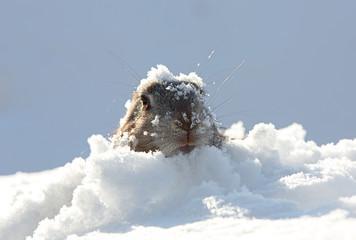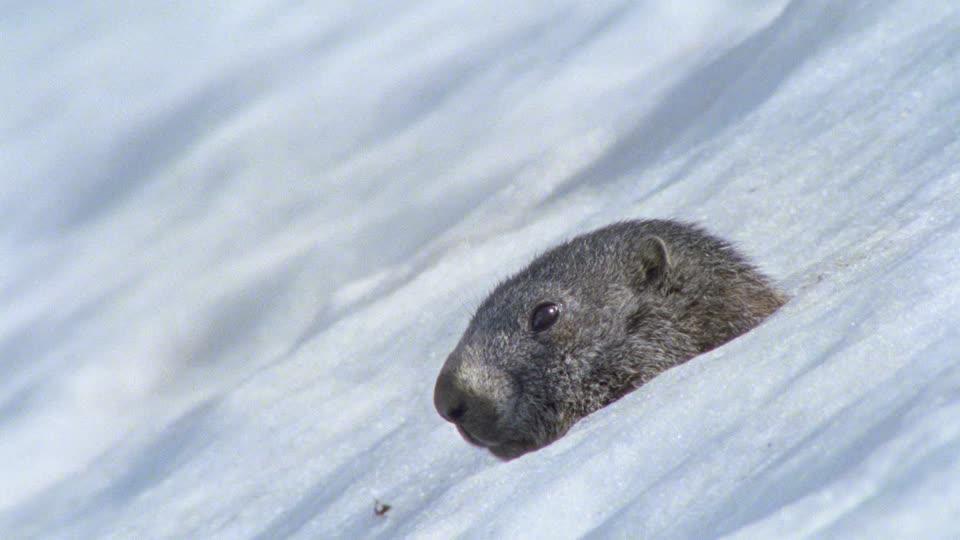The first image is the image on the left, the second image is the image on the right. For the images shown, is this caption "There are 4 prairie dogs and 2 are up on their hind legs." true? Answer yes or no. No. The first image is the image on the left, the second image is the image on the right. Evaluate the accuracy of this statement regarding the images: "There are at least 1 woodchuck poking its head out of the snow.". Is it true? Answer yes or no. Yes. 